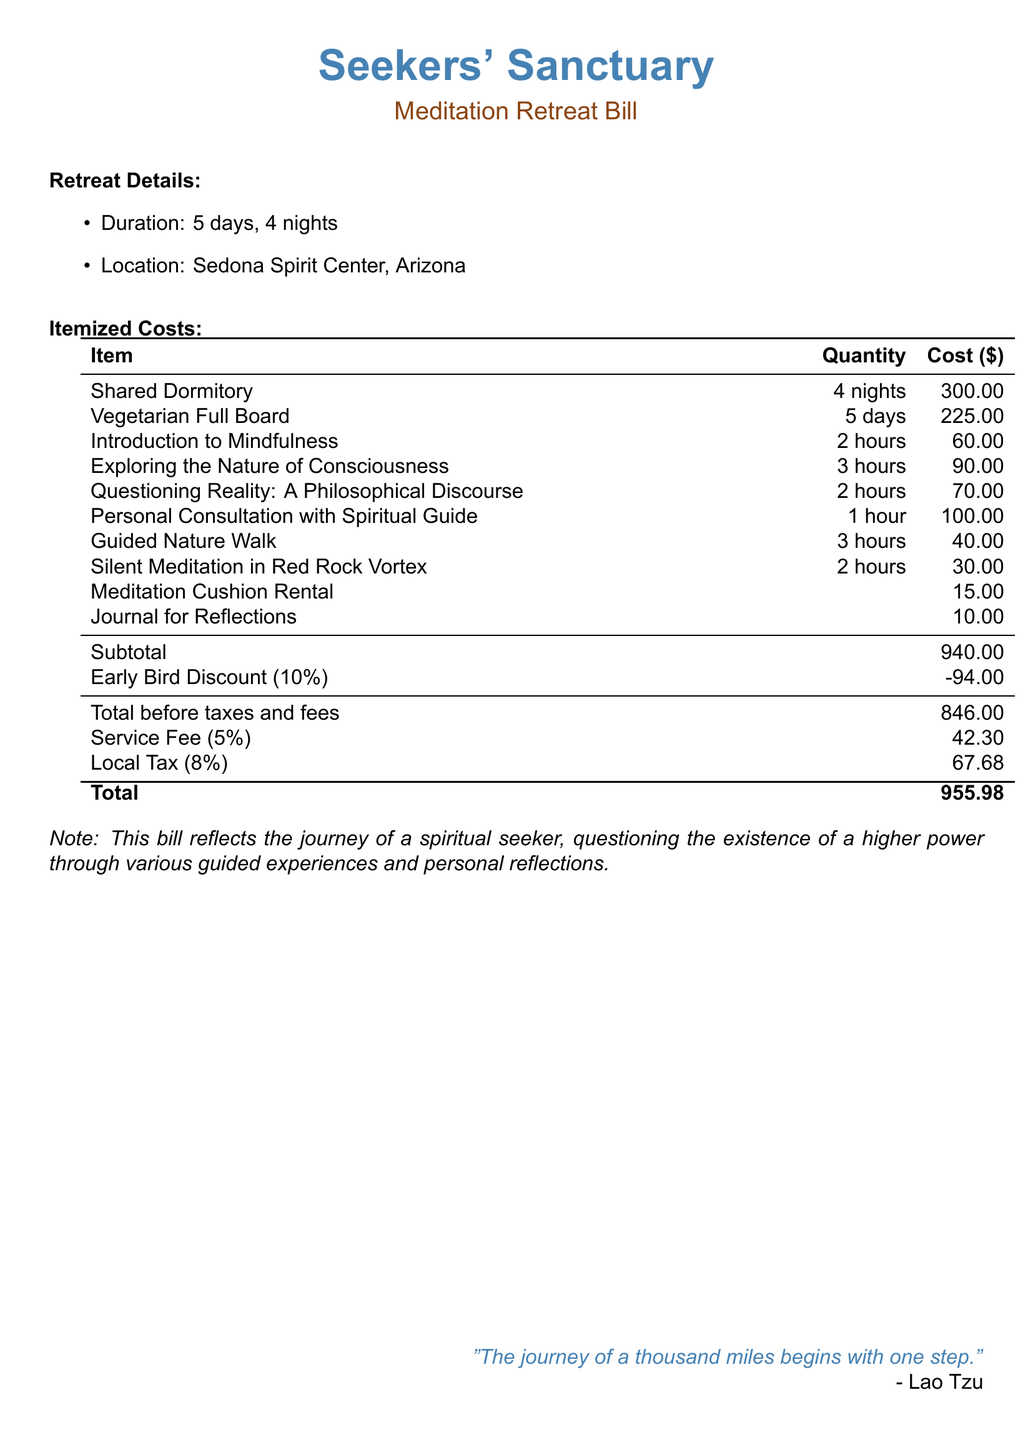What is the location of the meditation retreat? The document specifies the location as Sedona Spirit Center, Arizona.
Answer: Sedona Spirit Center, Arizona How many nights is the retreat? The retreat lasts for a duration of 5 days and includes 4 nights.
Answer: 4 nights What is the subtotal cost before discounts? The subtotal cost listed before applying discounts is $940.00.
Answer: 940.00 What percentage is the early bird discount? The document states that the early bird discount is 10%.
Answer: 10% How much does the personal consultation with a spiritual guide cost? The cost for the personal consultation with a spiritual guide is $100.00.
Answer: 100.00 What is the total cost after service fee and local tax? The total cost includes all fees and taxes, summing up to $955.98.
Answer: 955.98 How many hours are allocated for the "Exploring the Nature of Consciousness" session? The session "Exploring the Nature of Consciousness" is allocated 3 hours.
Answer: 3 hours What is the total service fee charged? The service fee is listed as 5% of the total, which is $42.30.
Answer: 42.30 What item is available for rent? The document lists a meditation cushion as available for rent.
Answer: Meditation Cushion Rental 